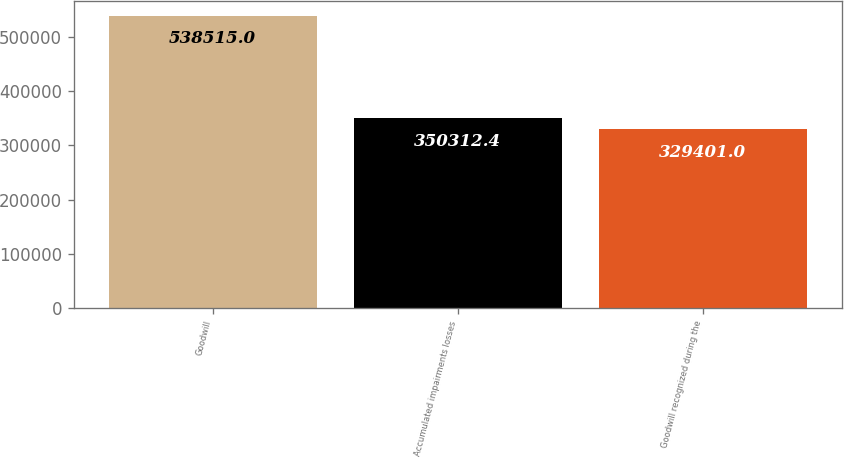<chart> <loc_0><loc_0><loc_500><loc_500><bar_chart><fcel>Goodwill<fcel>Accumulated impairments losses<fcel>Goodwill recognized during the<nl><fcel>538515<fcel>350312<fcel>329401<nl></chart> 